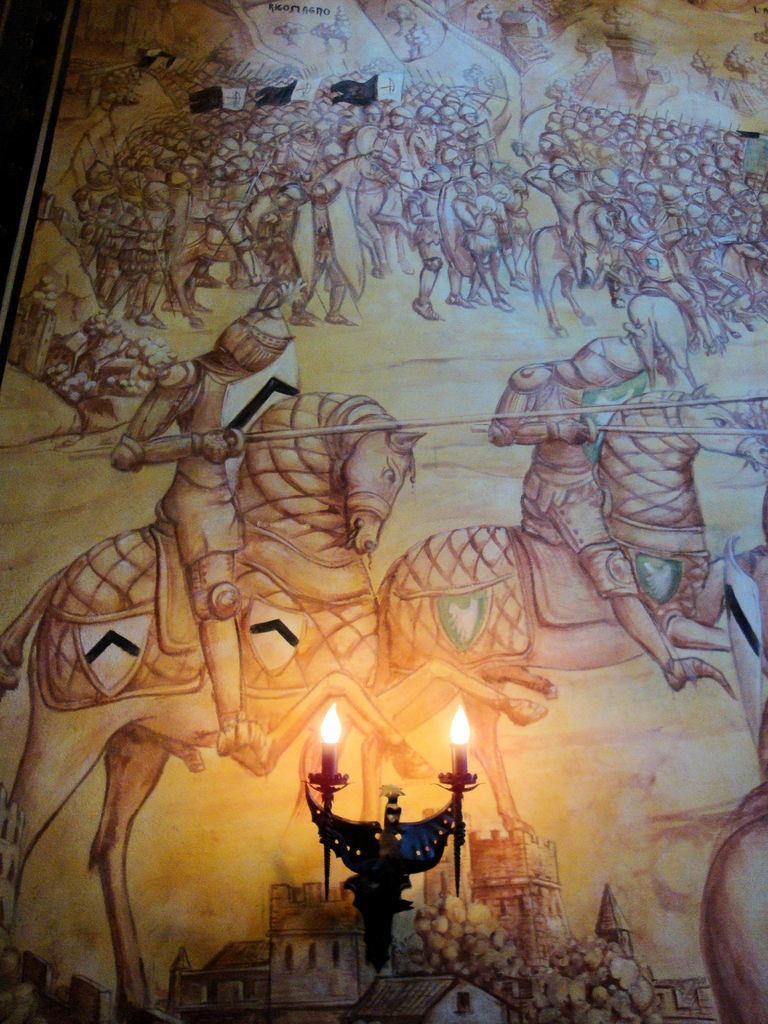Could you give a brief overview of what you see in this image? In this image, we can see a painting on the wall. At the bottom of the image, we can see a stand with lights. In this painting, we can see few people are riding horses. 